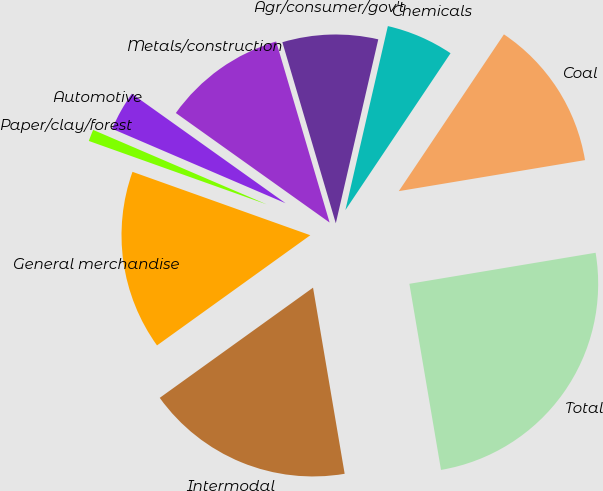Convert chart to OTSL. <chart><loc_0><loc_0><loc_500><loc_500><pie_chart><fcel>Coal<fcel>Chemicals<fcel>Agr/consumer/gov't<fcel>Metals/construction<fcel>Automotive<fcel>Paper/clay/forest<fcel>General merchandise<fcel>Intermodal<fcel>Total<nl><fcel>12.97%<fcel>5.79%<fcel>8.18%<fcel>10.58%<fcel>3.4%<fcel>1.0%<fcel>15.37%<fcel>17.76%<fcel>24.95%<nl></chart> 